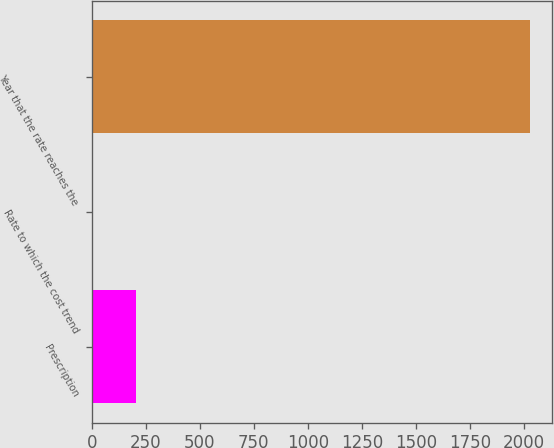<chart> <loc_0><loc_0><loc_500><loc_500><bar_chart><fcel>Prescription<fcel>Rate to which the cost trend<fcel>Year that the rate reaches the<nl><fcel>206.95<fcel>4.5<fcel>2029<nl></chart> 